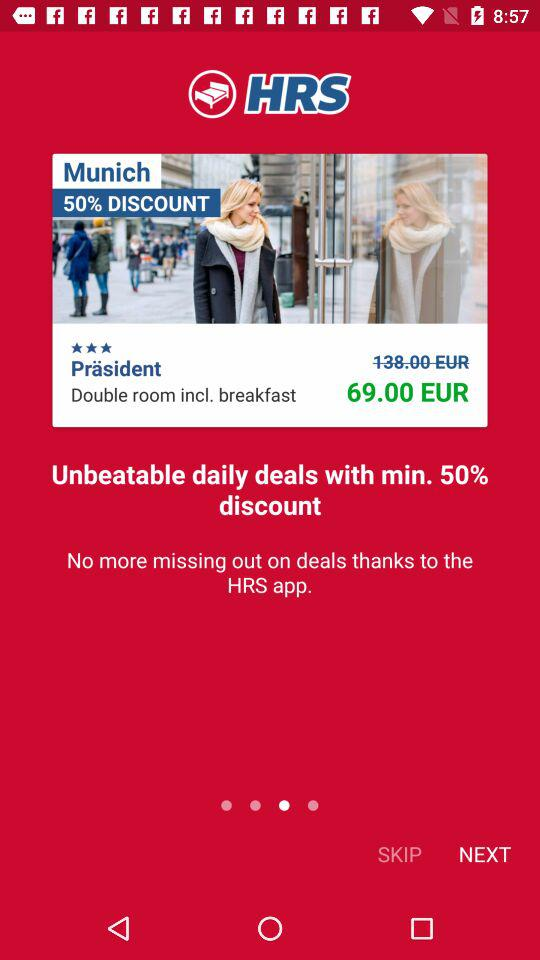What is the lowest percentage discount I can get on daily deals? The lowest percentage discount you can get on daily deals is 50. 